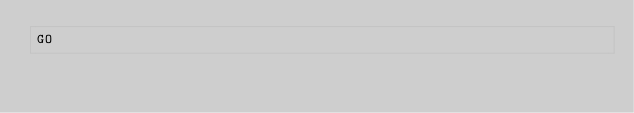Convert code to text. <code><loc_0><loc_0><loc_500><loc_500><_SQL_>GO


</code> 